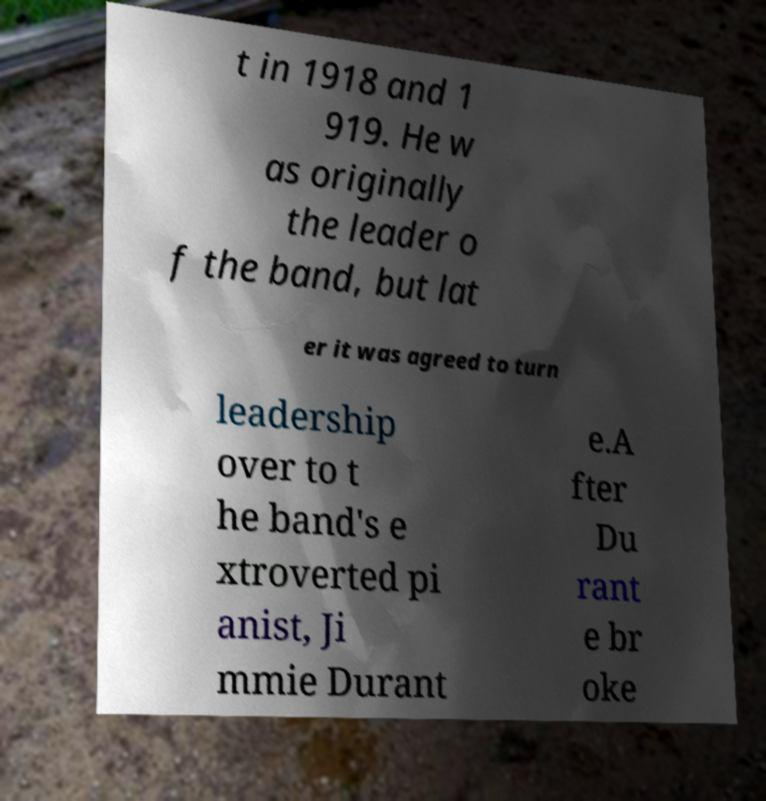For documentation purposes, I need the text within this image transcribed. Could you provide that? t in 1918 and 1 919. He w as originally the leader o f the band, but lat er it was agreed to turn leadership over to t he band's e xtroverted pi anist, Ji mmie Durant e.A fter Du rant e br oke 